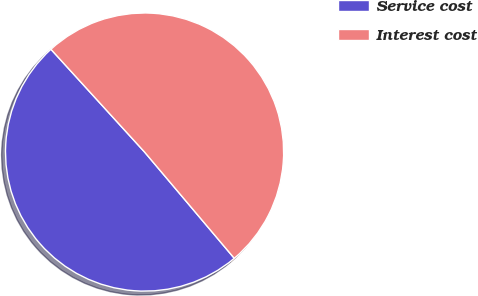Convert chart. <chart><loc_0><loc_0><loc_500><loc_500><pie_chart><fcel>Service cost<fcel>Interest cost<nl><fcel>49.4%<fcel>50.6%<nl></chart> 